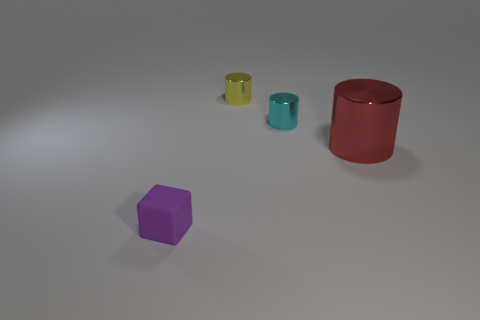Add 4 large red cylinders. How many objects exist? 8 Subtract all cylinders. How many objects are left? 1 Subtract all tiny cyan things. Subtract all purple matte things. How many objects are left? 2 Add 3 cyan objects. How many cyan objects are left? 4 Add 1 tiny yellow things. How many tiny yellow things exist? 2 Subtract 0 purple spheres. How many objects are left? 4 